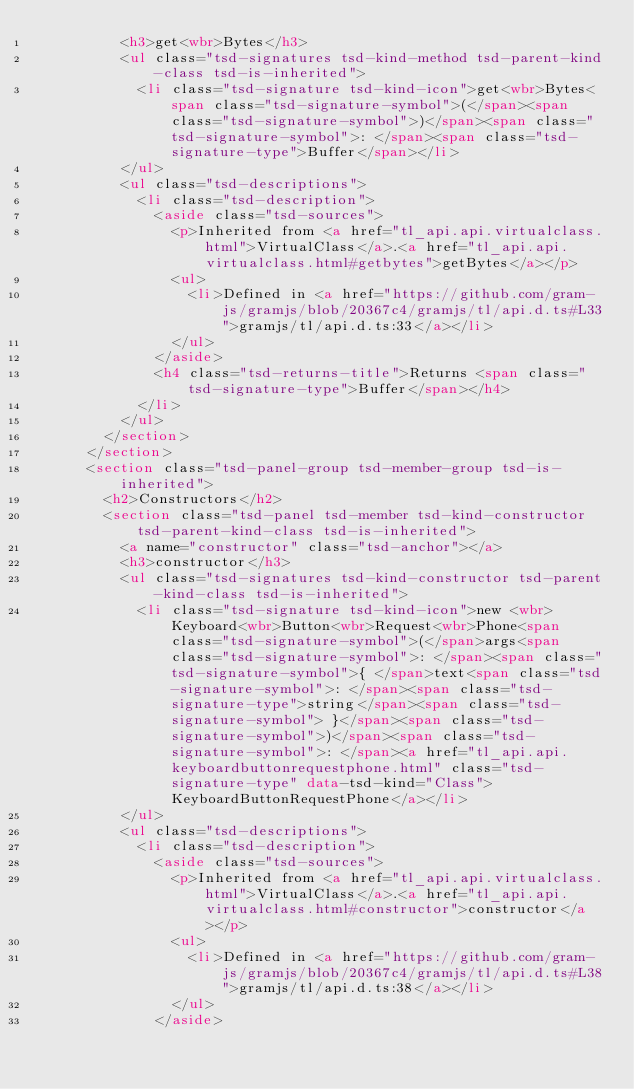Convert code to text. <code><loc_0><loc_0><loc_500><loc_500><_HTML_>					<h3>get<wbr>Bytes</h3>
					<ul class="tsd-signatures tsd-kind-method tsd-parent-kind-class tsd-is-inherited">
						<li class="tsd-signature tsd-kind-icon">get<wbr>Bytes<span class="tsd-signature-symbol">(</span><span class="tsd-signature-symbol">)</span><span class="tsd-signature-symbol">: </span><span class="tsd-signature-type">Buffer</span></li>
					</ul>
					<ul class="tsd-descriptions">
						<li class="tsd-description">
							<aside class="tsd-sources">
								<p>Inherited from <a href="tl_api.api.virtualclass.html">VirtualClass</a>.<a href="tl_api.api.virtualclass.html#getbytes">getBytes</a></p>
								<ul>
									<li>Defined in <a href="https://github.com/gram-js/gramjs/blob/20367c4/gramjs/tl/api.d.ts#L33">gramjs/tl/api.d.ts:33</a></li>
								</ul>
							</aside>
							<h4 class="tsd-returns-title">Returns <span class="tsd-signature-type">Buffer</span></h4>
						</li>
					</ul>
				</section>
			</section>
			<section class="tsd-panel-group tsd-member-group tsd-is-inherited">
				<h2>Constructors</h2>
				<section class="tsd-panel tsd-member tsd-kind-constructor tsd-parent-kind-class tsd-is-inherited">
					<a name="constructor" class="tsd-anchor"></a>
					<h3>constructor</h3>
					<ul class="tsd-signatures tsd-kind-constructor tsd-parent-kind-class tsd-is-inherited">
						<li class="tsd-signature tsd-kind-icon">new <wbr>Keyboard<wbr>Button<wbr>Request<wbr>Phone<span class="tsd-signature-symbol">(</span>args<span class="tsd-signature-symbol">: </span><span class="tsd-signature-symbol">{ </span>text<span class="tsd-signature-symbol">: </span><span class="tsd-signature-type">string</span><span class="tsd-signature-symbol"> }</span><span class="tsd-signature-symbol">)</span><span class="tsd-signature-symbol">: </span><a href="tl_api.api.keyboardbuttonrequestphone.html" class="tsd-signature-type" data-tsd-kind="Class">KeyboardButtonRequestPhone</a></li>
					</ul>
					<ul class="tsd-descriptions">
						<li class="tsd-description">
							<aside class="tsd-sources">
								<p>Inherited from <a href="tl_api.api.virtualclass.html">VirtualClass</a>.<a href="tl_api.api.virtualclass.html#constructor">constructor</a></p>
								<ul>
									<li>Defined in <a href="https://github.com/gram-js/gramjs/blob/20367c4/gramjs/tl/api.d.ts#L38">gramjs/tl/api.d.ts:38</a></li>
								</ul>
							</aside></code> 